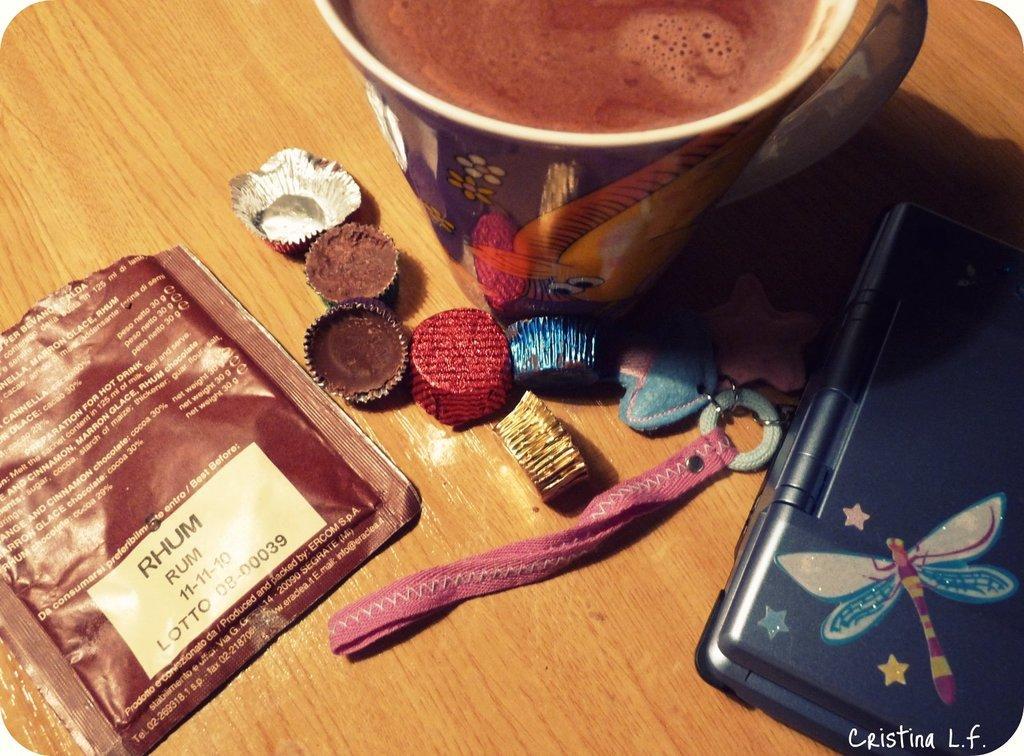Describe this image in one or two sentences. Here we can see a food packet, chocolates, mug with drink, and an object on a wooden platform. There is a watermark. 